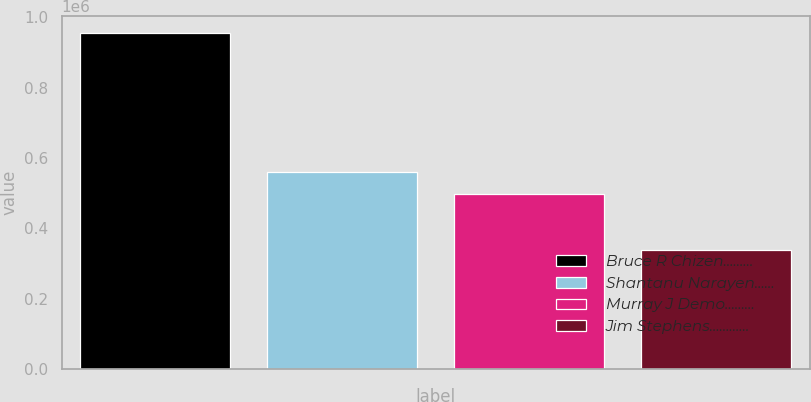Convert chart to OTSL. <chart><loc_0><loc_0><loc_500><loc_500><bar_chart><fcel>Bruce R Chizen………<fcel>Shantanu Narayen……<fcel>Murray J Demo………<fcel>Jim Stephens…………<nl><fcel>956252<fcel>560732<fcel>498961<fcel>338544<nl></chart> 